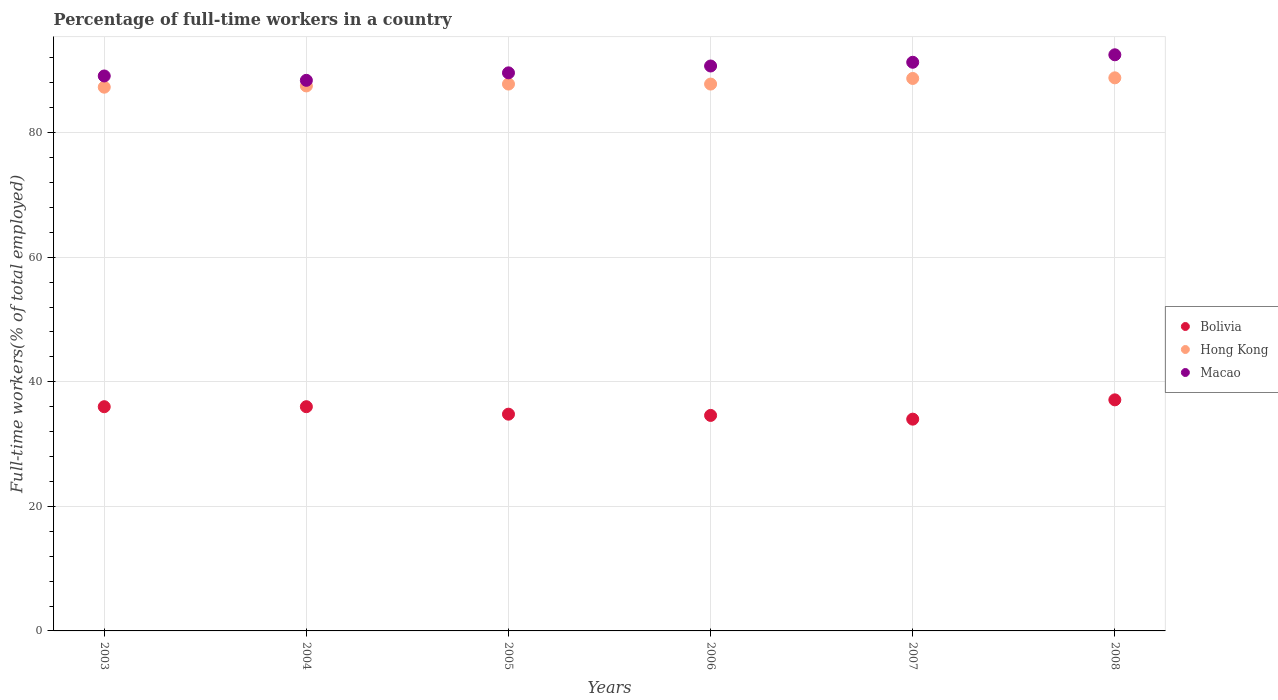How many different coloured dotlines are there?
Keep it short and to the point. 3. Is the number of dotlines equal to the number of legend labels?
Give a very brief answer. Yes. What is the percentage of full-time workers in Bolivia in 2005?
Give a very brief answer. 34.8. Across all years, what is the maximum percentage of full-time workers in Macao?
Your answer should be compact. 92.5. Across all years, what is the minimum percentage of full-time workers in Hong Kong?
Your answer should be very brief. 87.3. In which year was the percentage of full-time workers in Bolivia maximum?
Keep it short and to the point. 2008. What is the total percentage of full-time workers in Macao in the graph?
Offer a very short reply. 541.6. What is the difference between the percentage of full-time workers in Macao in 2006 and that in 2007?
Provide a succinct answer. -0.6. What is the difference between the percentage of full-time workers in Hong Kong in 2006 and the percentage of full-time workers in Bolivia in 2008?
Provide a succinct answer. 50.7. What is the average percentage of full-time workers in Macao per year?
Give a very brief answer. 90.27. In the year 2008, what is the difference between the percentage of full-time workers in Macao and percentage of full-time workers in Bolivia?
Your response must be concise. 55.4. What is the ratio of the percentage of full-time workers in Hong Kong in 2003 to that in 2004?
Ensure brevity in your answer.  1. Is the percentage of full-time workers in Hong Kong in 2005 less than that in 2006?
Make the answer very short. No. What is the difference between the highest and the second highest percentage of full-time workers in Bolivia?
Give a very brief answer. 1.1. What is the difference between the highest and the lowest percentage of full-time workers in Hong Kong?
Provide a short and direct response. 1.5. Is the sum of the percentage of full-time workers in Macao in 2005 and 2007 greater than the maximum percentage of full-time workers in Hong Kong across all years?
Offer a very short reply. Yes. Is it the case that in every year, the sum of the percentage of full-time workers in Hong Kong and percentage of full-time workers in Macao  is greater than the percentage of full-time workers in Bolivia?
Your answer should be very brief. Yes. Is the percentage of full-time workers in Hong Kong strictly greater than the percentage of full-time workers in Bolivia over the years?
Ensure brevity in your answer.  Yes. Is the percentage of full-time workers in Macao strictly less than the percentage of full-time workers in Bolivia over the years?
Provide a succinct answer. No. How many years are there in the graph?
Provide a succinct answer. 6. What is the difference between two consecutive major ticks on the Y-axis?
Ensure brevity in your answer.  20. Does the graph contain any zero values?
Offer a very short reply. No. Where does the legend appear in the graph?
Your response must be concise. Center right. How many legend labels are there?
Your response must be concise. 3. What is the title of the graph?
Keep it short and to the point. Percentage of full-time workers in a country. What is the label or title of the X-axis?
Make the answer very short. Years. What is the label or title of the Y-axis?
Give a very brief answer. Full-time workers(% of total employed). What is the Full-time workers(% of total employed) of Hong Kong in 2003?
Keep it short and to the point. 87.3. What is the Full-time workers(% of total employed) in Macao in 2003?
Provide a succinct answer. 89.1. What is the Full-time workers(% of total employed) in Bolivia in 2004?
Offer a terse response. 36. What is the Full-time workers(% of total employed) in Hong Kong in 2004?
Provide a short and direct response. 87.5. What is the Full-time workers(% of total employed) in Macao in 2004?
Offer a terse response. 88.4. What is the Full-time workers(% of total employed) in Bolivia in 2005?
Provide a succinct answer. 34.8. What is the Full-time workers(% of total employed) of Hong Kong in 2005?
Make the answer very short. 87.8. What is the Full-time workers(% of total employed) of Macao in 2005?
Your answer should be very brief. 89.6. What is the Full-time workers(% of total employed) in Bolivia in 2006?
Your response must be concise. 34.6. What is the Full-time workers(% of total employed) of Hong Kong in 2006?
Keep it short and to the point. 87.8. What is the Full-time workers(% of total employed) of Macao in 2006?
Give a very brief answer. 90.7. What is the Full-time workers(% of total employed) in Bolivia in 2007?
Offer a very short reply. 34. What is the Full-time workers(% of total employed) in Hong Kong in 2007?
Provide a short and direct response. 88.7. What is the Full-time workers(% of total employed) in Macao in 2007?
Your response must be concise. 91.3. What is the Full-time workers(% of total employed) in Bolivia in 2008?
Your answer should be compact. 37.1. What is the Full-time workers(% of total employed) of Hong Kong in 2008?
Ensure brevity in your answer.  88.8. What is the Full-time workers(% of total employed) in Macao in 2008?
Make the answer very short. 92.5. Across all years, what is the maximum Full-time workers(% of total employed) of Bolivia?
Offer a terse response. 37.1. Across all years, what is the maximum Full-time workers(% of total employed) in Hong Kong?
Keep it short and to the point. 88.8. Across all years, what is the maximum Full-time workers(% of total employed) in Macao?
Give a very brief answer. 92.5. Across all years, what is the minimum Full-time workers(% of total employed) of Hong Kong?
Provide a short and direct response. 87.3. Across all years, what is the minimum Full-time workers(% of total employed) in Macao?
Offer a terse response. 88.4. What is the total Full-time workers(% of total employed) of Bolivia in the graph?
Offer a terse response. 212.5. What is the total Full-time workers(% of total employed) in Hong Kong in the graph?
Make the answer very short. 527.9. What is the total Full-time workers(% of total employed) in Macao in the graph?
Your response must be concise. 541.6. What is the difference between the Full-time workers(% of total employed) in Bolivia in 2003 and that in 2004?
Give a very brief answer. 0. What is the difference between the Full-time workers(% of total employed) in Hong Kong in 2003 and that in 2004?
Offer a terse response. -0.2. What is the difference between the Full-time workers(% of total employed) of Macao in 2003 and that in 2004?
Offer a terse response. 0.7. What is the difference between the Full-time workers(% of total employed) in Macao in 2003 and that in 2005?
Provide a short and direct response. -0.5. What is the difference between the Full-time workers(% of total employed) in Macao in 2003 and that in 2006?
Your answer should be very brief. -1.6. What is the difference between the Full-time workers(% of total employed) of Bolivia in 2003 and that in 2007?
Provide a short and direct response. 2. What is the difference between the Full-time workers(% of total employed) of Hong Kong in 2003 and that in 2008?
Offer a terse response. -1.5. What is the difference between the Full-time workers(% of total employed) in Macao in 2003 and that in 2008?
Your answer should be very brief. -3.4. What is the difference between the Full-time workers(% of total employed) of Bolivia in 2004 and that in 2005?
Your answer should be compact. 1.2. What is the difference between the Full-time workers(% of total employed) in Macao in 2004 and that in 2005?
Your response must be concise. -1.2. What is the difference between the Full-time workers(% of total employed) of Bolivia in 2004 and that in 2007?
Provide a short and direct response. 2. What is the difference between the Full-time workers(% of total employed) of Hong Kong in 2004 and that in 2007?
Provide a short and direct response. -1.2. What is the difference between the Full-time workers(% of total employed) of Bolivia in 2004 and that in 2008?
Keep it short and to the point. -1.1. What is the difference between the Full-time workers(% of total employed) in Hong Kong in 2004 and that in 2008?
Provide a succinct answer. -1.3. What is the difference between the Full-time workers(% of total employed) in Macao in 2004 and that in 2008?
Provide a short and direct response. -4.1. What is the difference between the Full-time workers(% of total employed) in Hong Kong in 2005 and that in 2006?
Provide a short and direct response. 0. What is the difference between the Full-time workers(% of total employed) of Bolivia in 2005 and that in 2007?
Provide a succinct answer. 0.8. What is the difference between the Full-time workers(% of total employed) of Macao in 2005 and that in 2007?
Provide a short and direct response. -1.7. What is the difference between the Full-time workers(% of total employed) of Hong Kong in 2005 and that in 2008?
Keep it short and to the point. -1. What is the difference between the Full-time workers(% of total employed) of Bolivia in 2006 and that in 2007?
Provide a succinct answer. 0.6. What is the difference between the Full-time workers(% of total employed) in Macao in 2006 and that in 2007?
Your answer should be very brief. -0.6. What is the difference between the Full-time workers(% of total employed) in Bolivia in 2003 and the Full-time workers(% of total employed) in Hong Kong in 2004?
Keep it short and to the point. -51.5. What is the difference between the Full-time workers(% of total employed) in Bolivia in 2003 and the Full-time workers(% of total employed) in Macao in 2004?
Offer a terse response. -52.4. What is the difference between the Full-time workers(% of total employed) of Bolivia in 2003 and the Full-time workers(% of total employed) of Hong Kong in 2005?
Ensure brevity in your answer.  -51.8. What is the difference between the Full-time workers(% of total employed) in Bolivia in 2003 and the Full-time workers(% of total employed) in Macao in 2005?
Offer a terse response. -53.6. What is the difference between the Full-time workers(% of total employed) of Bolivia in 2003 and the Full-time workers(% of total employed) of Hong Kong in 2006?
Your answer should be compact. -51.8. What is the difference between the Full-time workers(% of total employed) of Bolivia in 2003 and the Full-time workers(% of total employed) of Macao in 2006?
Make the answer very short. -54.7. What is the difference between the Full-time workers(% of total employed) in Bolivia in 2003 and the Full-time workers(% of total employed) in Hong Kong in 2007?
Give a very brief answer. -52.7. What is the difference between the Full-time workers(% of total employed) in Bolivia in 2003 and the Full-time workers(% of total employed) in Macao in 2007?
Keep it short and to the point. -55.3. What is the difference between the Full-time workers(% of total employed) in Hong Kong in 2003 and the Full-time workers(% of total employed) in Macao in 2007?
Ensure brevity in your answer.  -4. What is the difference between the Full-time workers(% of total employed) in Bolivia in 2003 and the Full-time workers(% of total employed) in Hong Kong in 2008?
Offer a terse response. -52.8. What is the difference between the Full-time workers(% of total employed) in Bolivia in 2003 and the Full-time workers(% of total employed) in Macao in 2008?
Provide a succinct answer. -56.5. What is the difference between the Full-time workers(% of total employed) in Bolivia in 2004 and the Full-time workers(% of total employed) in Hong Kong in 2005?
Make the answer very short. -51.8. What is the difference between the Full-time workers(% of total employed) in Bolivia in 2004 and the Full-time workers(% of total employed) in Macao in 2005?
Provide a succinct answer. -53.6. What is the difference between the Full-time workers(% of total employed) of Bolivia in 2004 and the Full-time workers(% of total employed) of Hong Kong in 2006?
Provide a succinct answer. -51.8. What is the difference between the Full-time workers(% of total employed) of Bolivia in 2004 and the Full-time workers(% of total employed) of Macao in 2006?
Give a very brief answer. -54.7. What is the difference between the Full-time workers(% of total employed) in Bolivia in 2004 and the Full-time workers(% of total employed) in Hong Kong in 2007?
Offer a very short reply. -52.7. What is the difference between the Full-time workers(% of total employed) of Bolivia in 2004 and the Full-time workers(% of total employed) of Macao in 2007?
Offer a terse response. -55.3. What is the difference between the Full-time workers(% of total employed) of Hong Kong in 2004 and the Full-time workers(% of total employed) of Macao in 2007?
Offer a terse response. -3.8. What is the difference between the Full-time workers(% of total employed) of Bolivia in 2004 and the Full-time workers(% of total employed) of Hong Kong in 2008?
Offer a terse response. -52.8. What is the difference between the Full-time workers(% of total employed) of Bolivia in 2004 and the Full-time workers(% of total employed) of Macao in 2008?
Give a very brief answer. -56.5. What is the difference between the Full-time workers(% of total employed) of Hong Kong in 2004 and the Full-time workers(% of total employed) of Macao in 2008?
Provide a succinct answer. -5. What is the difference between the Full-time workers(% of total employed) of Bolivia in 2005 and the Full-time workers(% of total employed) of Hong Kong in 2006?
Ensure brevity in your answer.  -53. What is the difference between the Full-time workers(% of total employed) in Bolivia in 2005 and the Full-time workers(% of total employed) in Macao in 2006?
Provide a succinct answer. -55.9. What is the difference between the Full-time workers(% of total employed) of Hong Kong in 2005 and the Full-time workers(% of total employed) of Macao in 2006?
Your answer should be very brief. -2.9. What is the difference between the Full-time workers(% of total employed) in Bolivia in 2005 and the Full-time workers(% of total employed) in Hong Kong in 2007?
Your answer should be compact. -53.9. What is the difference between the Full-time workers(% of total employed) of Bolivia in 2005 and the Full-time workers(% of total employed) of Macao in 2007?
Provide a succinct answer. -56.5. What is the difference between the Full-time workers(% of total employed) of Hong Kong in 2005 and the Full-time workers(% of total employed) of Macao in 2007?
Provide a succinct answer. -3.5. What is the difference between the Full-time workers(% of total employed) in Bolivia in 2005 and the Full-time workers(% of total employed) in Hong Kong in 2008?
Ensure brevity in your answer.  -54. What is the difference between the Full-time workers(% of total employed) in Bolivia in 2005 and the Full-time workers(% of total employed) in Macao in 2008?
Make the answer very short. -57.7. What is the difference between the Full-time workers(% of total employed) of Hong Kong in 2005 and the Full-time workers(% of total employed) of Macao in 2008?
Provide a short and direct response. -4.7. What is the difference between the Full-time workers(% of total employed) in Bolivia in 2006 and the Full-time workers(% of total employed) in Hong Kong in 2007?
Your response must be concise. -54.1. What is the difference between the Full-time workers(% of total employed) in Bolivia in 2006 and the Full-time workers(% of total employed) in Macao in 2007?
Ensure brevity in your answer.  -56.7. What is the difference between the Full-time workers(% of total employed) in Hong Kong in 2006 and the Full-time workers(% of total employed) in Macao in 2007?
Provide a succinct answer. -3.5. What is the difference between the Full-time workers(% of total employed) in Bolivia in 2006 and the Full-time workers(% of total employed) in Hong Kong in 2008?
Your response must be concise. -54.2. What is the difference between the Full-time workers(% of total employed) in Bolivia in 2006 and the Full-time workers(% of total employed) in Macao in 2008?
Your response must be concise. -57.9. What is the difference between the Full-time workers(% of total employed) of Hong Kong in 2006 and the Full-time workers(% of total employed) of Macao in 2008?
Keep it short and to the point. -4.7. What is the difference between the Full-time workers(% of total employed) of Bolivia in 2007 and the Full-time workers(% of total employed) of Hong Kong in 2008?
Make the answer very short. -54.8. What is the difference between the Full-time workers(% of total employed) of Bolivia in 2007 and the Full-time workers(% of total employed) of Macao in 2008?
Provide a succinct answer. -58.5. What is the average Full-time workers(% of total employed) of Bolivia per year?
Your response must be concise. 35.42. What is the average Full-time workers(% of total employed) in Hong Kong per year?
Offer a terse response. 87.98. What is the average Full-time workers(% of total employed) in Macao per year?
Offer a terse response. 90.27. In the year 2003, what is the difference between the Full-time workers(% of total employed) of Bolivia and Full-time workers(% of total employed) of Hong Kong?
Give a very brief answer. -51.3. In the year 2003, what is the difference between the Full-time workers(% of total employed) in Bolivia and Full-time workers(% of total employed) in Macao?
Your answer should be very brief. -53.1. In the year 2003, what is the difference between the Full-time workers(% of total employed) of Hong Kong and Full-time workers(% of total employed) of Macao?
Ensure brevity in your answer.  -1.8. In the year 2004, what is the difference between the Full-time workers(% of total employed) of Bolivia and Full-time workers(% of total employed) of Hong Kong?
Give a very brief answer. -51.5. In the year 2004, what is the difference between the Full-time workers(% of total employed) of Bolivia and Full-time workers(% of total employed) of Macao?
Ensure brevity in your answer.  -52.4. In the year 2005, what is the difference between the Full-time workers(% of total employed) of Bolivia and Full-time workers(% of total employed) of Hong Kong?
Your answer should be very brief. -53. In the year 2005, what is the difference between the Full-time workers(% of total employed) in Bolivia and Full-time workers(% of total employed) in Macao?
Keep it short and to the point. -54.8. In the year 2006, what is the difference between the Full-time workers(% of total employed) in Bolivia and Full-time workers(% of total employed) in Hong Kong?
Keep it short and to the point. -53.2. In the year 2006, what is the difference between the Full-time workers(% of total employed) in Bolivia and Full-time workers(% of total employed) in Macao?
Offer a very short reply. -56.1. In the year 2006, what is the difference between the Full-time workers(% of total employed) of Hong Kong and Full-time workers(% of total employed) of Macao?
Give a very brief answer. -2.9. In the year 2007, what is the difference between the Full-time workers(% of total employed) in Bolivia and Full-time workers(% of total employed) in Hong Kong?
Ensure brevity in your answer.  -54.7. In the year 2007, what is the difference between the Full-time workers(% of total employed) of Bolivia and Full-time workers(% of total employed) of Macao?
Offer a very short reply. -57.3. In the year 2008, what is the difference between the Full-time workers(% of total employed) in Bolivia and Full-time workers(% of total employed) in Hong Kong?
Provide a short and direct response. -51.7. In the year 2008, what is the difference between the Full-time workers(% of total employed) in Bolivia and Full-time workers(% of total employed) in Macao?
Offer a very short reply. -55.4. What is the ratio of the Full-time workers(% of total employed) of Hong Kong in 2003 to that in 2004?
Provide a short and direct response. 1. What is the ratio of the Full-time workers(% of total employed) in Macao in 2003 to that in 2004?
Offer a terse response. 1.01. What is the ratio of the Full-time workers(% of total employed) of Bolivia in 2003 to that in 2005?
Offer a very short reply. 1.03. What is the ratio of the Full-time workers(% of total employed) of Hong Kong in 2003 to that in 2005?
Ensure brevity in your answer.  0.99. What is the ratio of the Full-time workers(% of total employed) in Bolivia in 2003 to that in 2006?
Offer a terse response. 1.04. What is the ratio of the Full-time workers(% of total employed) of Hong Kong in 2003 to that in 2006?
Offer a very short reply. 0.99. What is the ratio of the Full-time workers(% of total employed) of Macao in 2003 to that in 2006?
Offer a terse response. 0.98. What is the ratio of the Full-time workers(% of total employed) of Bolivia in 2003 to that in 2007?
Your answer should be compact. 1.06. What is the ratio of the Full-time workers(% of total employed) in Hong Kong in 2003 to that in 2007?
Keep it short and to the point. 0.98. What is the ratio of the Full-time workers(% of total employed) of Macao in 2003 to that in 2007?
Provide a succinct answer. 0.98. What is the ratio of the Full-time workers(% of total employed) in Bolivia in 2003 to that in 2008?
Offer a terse response. 0.97. What is the ratio of the Full-time workers(% of total employed) of Hong Kong in 2003 to that in 2008?
Offer a very short reply. 0.98. What is the ratio of the Full-time workers(% of total employed) of Macao in 2003 to that in 2008?
Make the answer very short. 0.96. What is the ratio of the Full-time workers(% of total employed) of Bolivia in 2004 to that in 2005?
Provide a short and direct response. 1.03. What is the ratio of the Full-time workers(% of total employed) in Macao in 2004 to that in 2005?
Provide a short and direct response. 0.99. What is the ratio of the Full-time workers(% of total employed) in Bolivia in 2004 to that in 2006?
Your answer should be compact. 1.04. What is the ratio of the Full-time workers(% of total employed) of Macao in 2004 to that in 2006?
Offer a terse response. 0.97. What is the ratio of the Full-time workers(% of total employed) in Bolivia in 2004 to that in 2007?
Offer a very short reply. 1.06. What is the ratio of the Full-time workers(% of total employed) of Hong Kong in 2004 to that in 2007?
Offer a very short reply. 0.99. What is the ratio of the Full-time workers(% of total employed) in Macao in 2004 to that in 2007?
Keep it short and to the point. 0.97. What is the ratio of the Full-time workers(% of total employed) of Bolivia in 2004 to that in 2008?
Ensure brevity in your answer.  0.97. What is the ratio of the Full-time workers(% of total employed) in Hong Kong in 2004 to that in 2008?
Offer a very short reply. 0.99. What is the ratio of the Full-time workers(% of total employed) of Macao in 2004 to that in 2008?
Keep it short and to the point. 0.96. What is the ratio of the Full-time workers(% of total employed) of Bolivia in 2005 to that in 2006?
Your response must be concise. 1.01. What is the ratio of the Full-time workers(% of total employed) of Macao in 2005 to that in 2006?
Your response must be concise. 0.99. What is the ratio of the Full-time workers(% of total employed) in Bolivia in 2005 to that in 2007?
Your response must be concise. 1.02. What is the ratio of the Full-time workers(% of total employed) of Macao in 2005 to that in 2007?
Your answer should be very brief. 0.98. What is the ratio of the Full-time workers(% of total employed) of Bolivia in 2005 to that in 2008?
Give a very brief answer. 0.94. What is the ratio of the Full-time workers(% of total employed) of Hong Kong in 2005 to that in 2008?
Offer a terse response. 0.99. What is the ratio of the Full-time workers(% of total employed) of Macao in 2005 to that in 2008?
Ensure brevity in your answer.  0.97. What is the ratio of the Full-time workers(% of total employed) in Bolivia in 2006 to that in 2007?
Offer a terse response. 1.02. What is the ratio of the Full-time workers(% of total employed) of Hong Kong in 2006 to that in 2007?
Your answer should be compact. 0.99. What is the ratio of the Full-time workers(% of total employed) of Macao in 2006 to that in 2007?
Your answer should be compact. 0.99. What is the ratio of the Full-time workers(% of total employed) of Bolivia in 2006 to that in 2008?
Give a very brief answer. 0.93. What is the ratio of the Full-time workers(% of total employed) of Hong Kong in 2006 to that in 2008?
Offer a terse response. 0.99. What is the ratio of the Full-time workers(% of total employed) of Macao in 2006 to that in 2008?
Offer a very short reply. 0.98. What is the ratio of the Full-time workers(% of total employed) of Bolivia in 2007 to that in 2008?
Offer a very short reply. 0.92. What is the difference between the highest and the second highest Full-time workers(% of total employed) of Bolivia?
Give a very brief answer. 1.1. What is the difference between the highest and the second highest Full-time workers(% of total employed) of Macao?
Your answer should be compact. 1.2. What is the difference between the highest and the lowest Full-time workers(% of total employed) of Macao?
Make the answer very short. 4.1. 